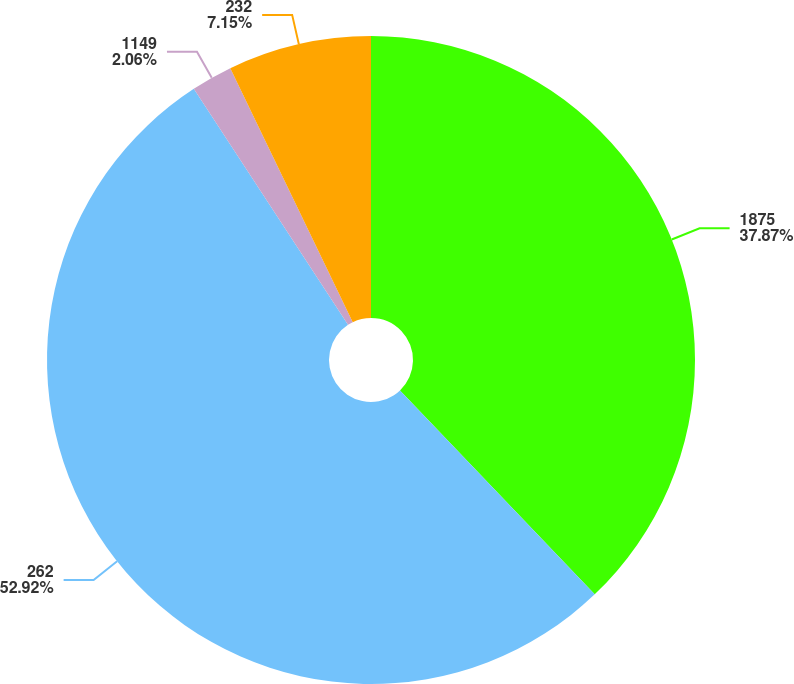<chart> <loc_0><loc_0><loc_500><loc_500><pie_chart><fcel>1875<fcel>262<fcel>1149<fcel>232<nl><fcel>37.87%<fcel>52.92%<fcel>2.06%<fcel>7.15%<nl></chart> 